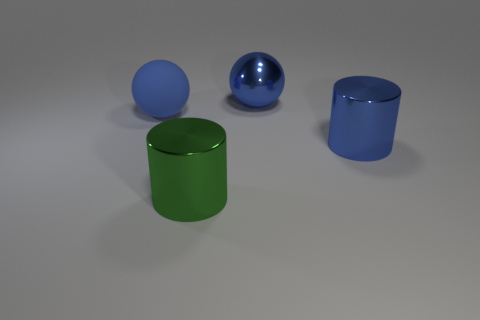There is a object in front of the large cylinder that is on the right side of the big shiny sphere; what size is it?
Offer a very short reply. Large. Is there a small gray cylinder?
Your answer should be compact. No. The thing that is to the left of the large blue metal ball and behind the green metallic thing is made of what material?
Offer a very short reply. Rubber. Are there more blue metal things in front of the matte object than green cylinders behind the big blue metal cylinder?
Provide a succinct answer. Yes. Is there a green thing of the same size as the matte sphere?
Your response must be concise. Yes. There is a metal cylinder that is in front of the large blue thing that is in front of the large blue ball left of the green shiny thing; what size is it?
Your response must be concise. Large. The big matte sphere is what color?
Make the answer very short. Blue. Are there more things that are right of the large blue rubber ball than blue balls?
Make the answer very short. Yes. How many blue rubber balls are in front of the green object?
Provide a succinct answer. 0. What is the shape of the large shiny object that is the same color as the large shiny sphere?
Ensure brevity in your answer.  Cylinder. 